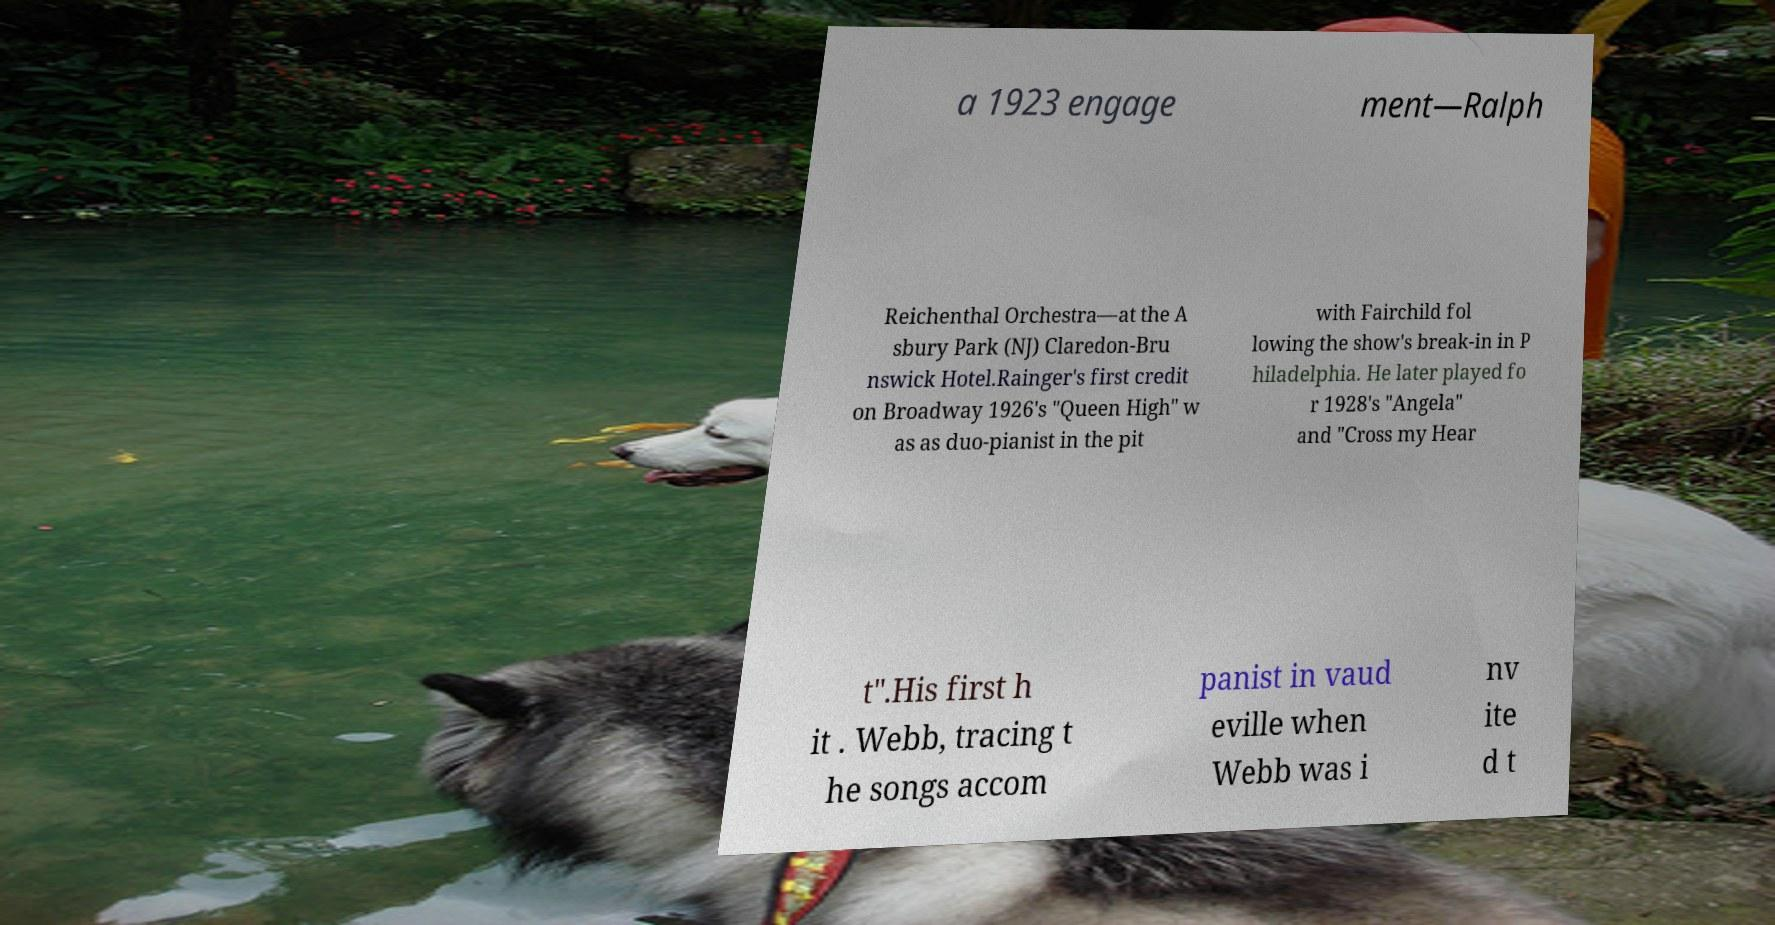I need the written content from this picture converted into text. Can you do that? a 1923 engage ment—Ralph Reichenthal Orchestra—at the A sbury Park (NJ) Claredon-Bru nswick Hotel.Rainger's first credit on Broadway 1926's "Queen High" w as as duo-pianist in the pit with Fairchild fol lowing the show's break-in in P hiladelphia. He later played fo r 1928's "Angela" and "Cross my Hear t".His first h it . Webb, tracing t he songs accom panist in vaud eville when Webb was i nv ite d t 